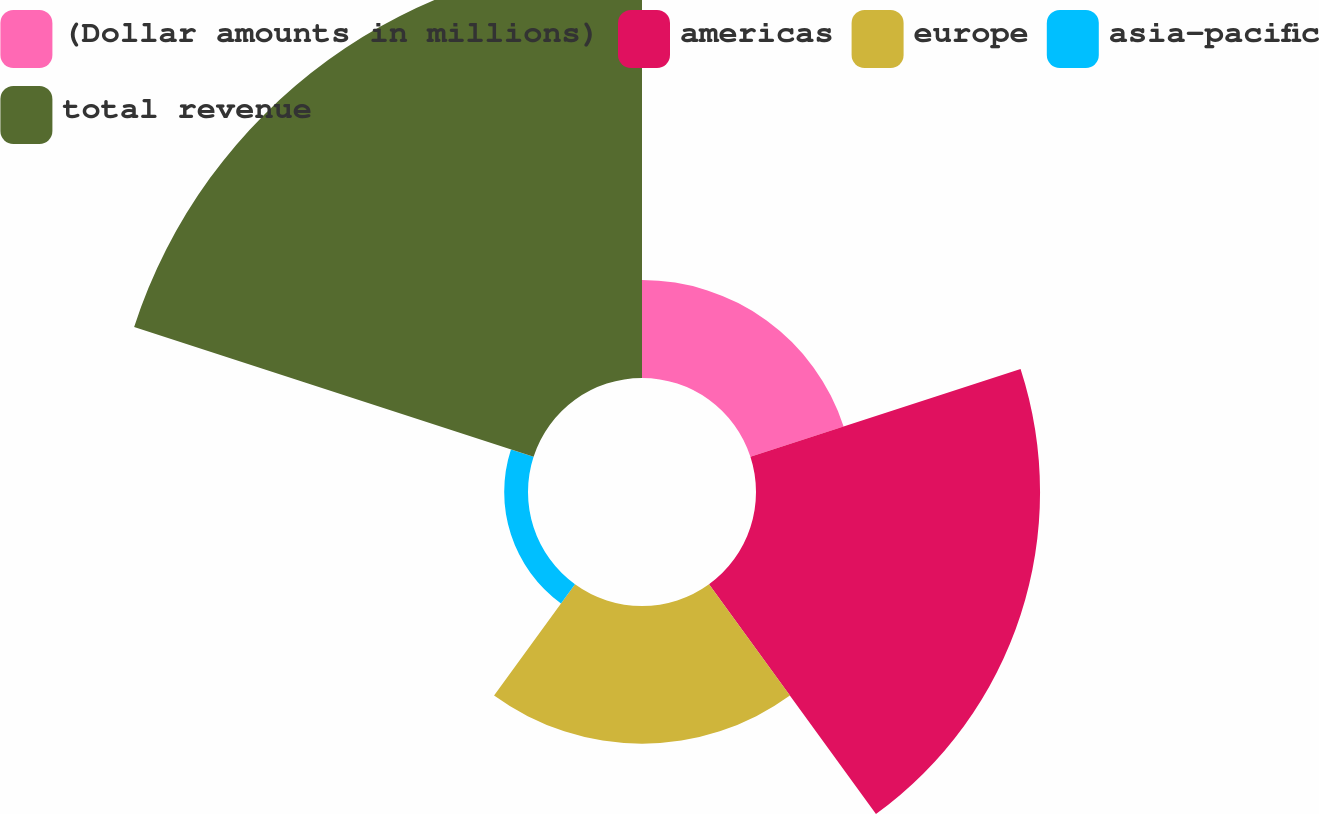Convert chart. <chart><loc_0><loc_0><loc_500><loc_500><pie_chart><fcel>(Dollar amounts in millions)<fcel>americas<fcel>europe<fcel>asia-pacific<fcel>total revenue<nl><fcel>10.17%<fcel>29.48%<fcel>14.29%<fcel>2.47%<fcel>43.59%<nl></chart> 